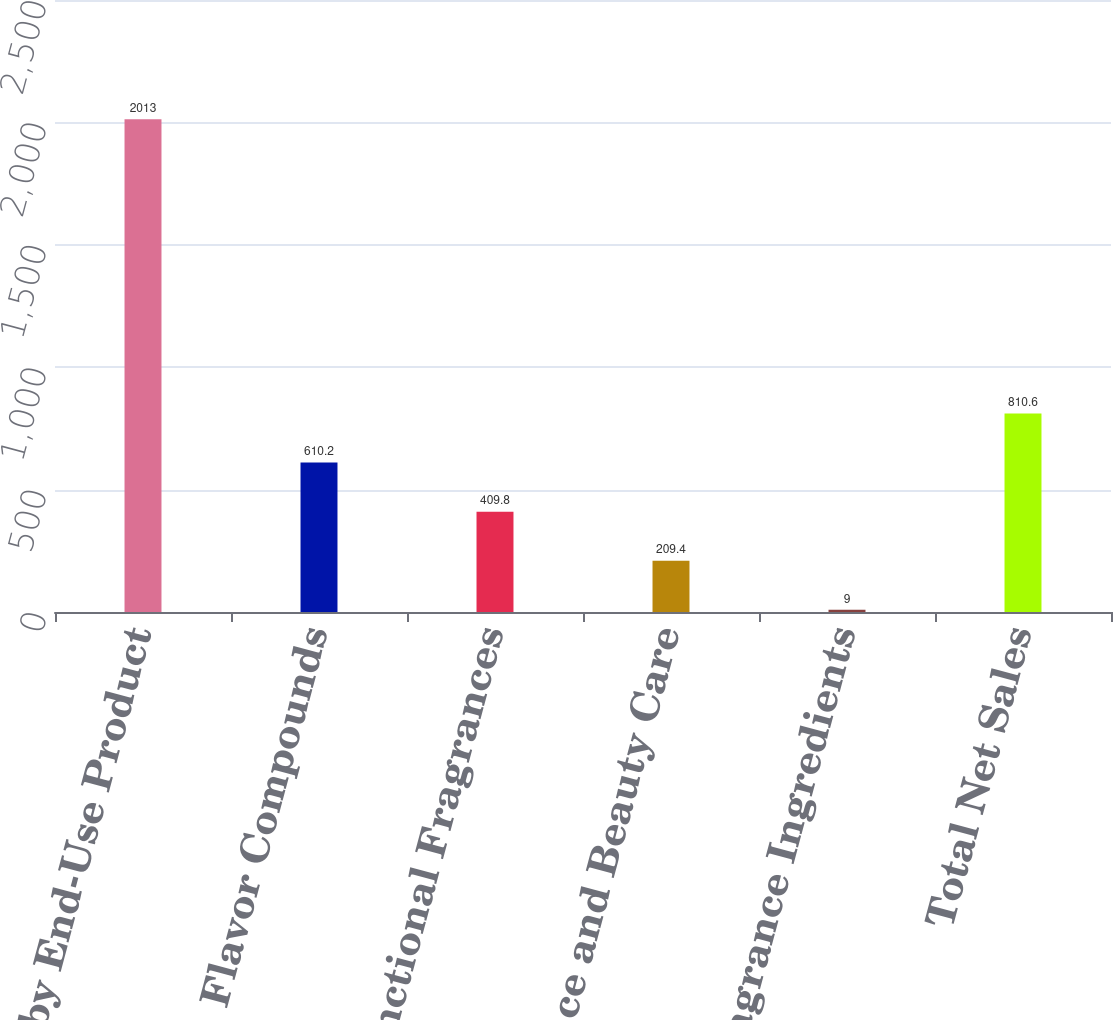Convert chart. <chart><loc_0><loc_0><loc_500><loc_500><bar_chart><fcel>Sales by End-Use Product<fcel>Flavor Compounds<fcel>Functional Fragrances<fcel>Fine Fragrance and Beauty Care<fcel>Fragrance Ingredients<fcel>Total Net Sales<nl><fcel>2013<fcel>610.2<fcel>409.8<fcel>209.4<fcel>9<fcel>810.6<nl></chart> 